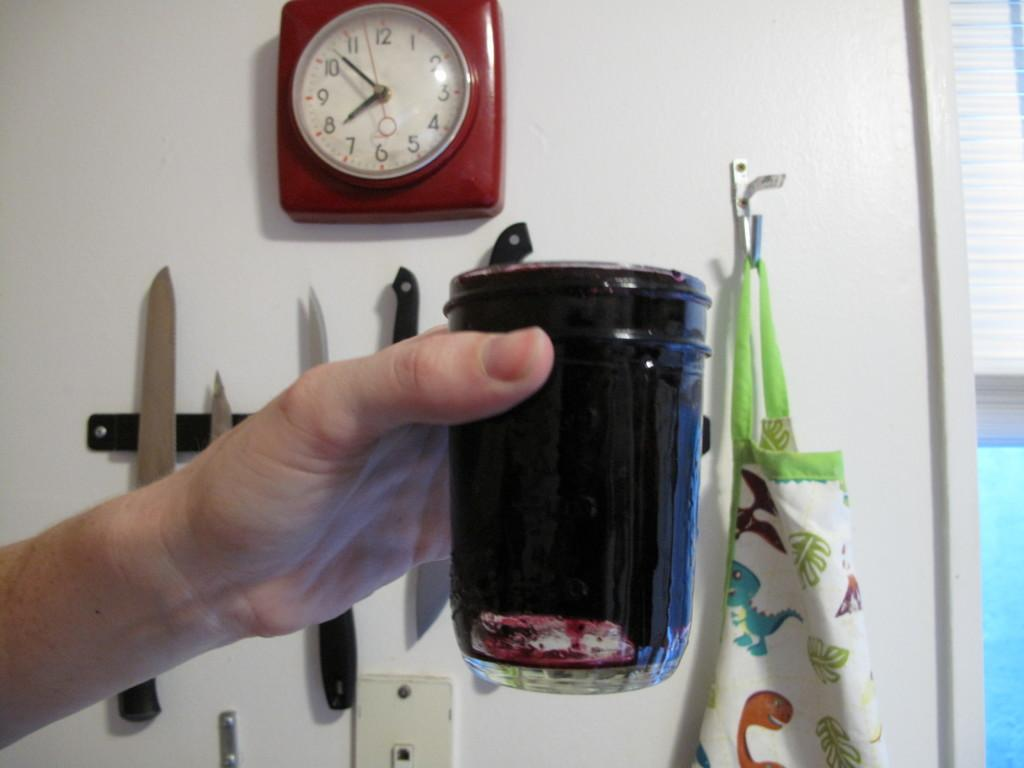<image>
Present a compact description of the photo's key features. A square red clock that shows it being eight until eight. 